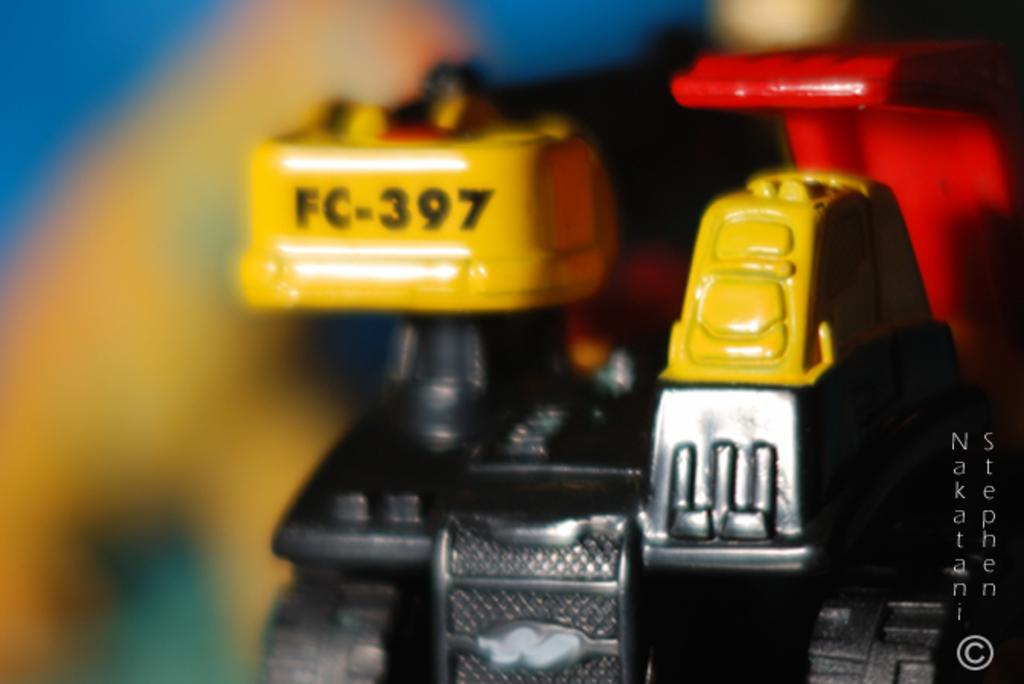What's the part number?
Provide a succinct answer. Fc-397. Who is credited with this photo?
Provide a short and direct response. Nakatani stephen. 